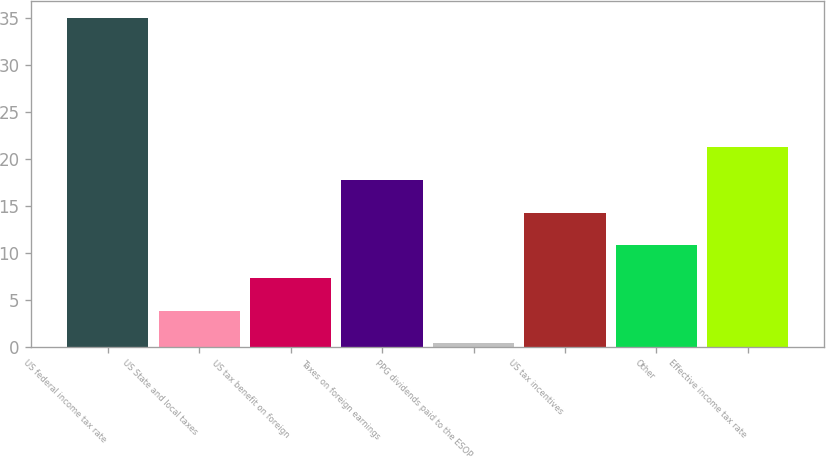<chart> <loc_0><loc_0><loc_500><loc_500><bar_chart><fcel>US federal income tax rate<fcel>US State and local taxes<fcel>US tax benefit on foreign<fcel>Taxes on foreign earnings<fcel>PPG dividends paid to the ESOP<fcel>US tax incentives<fcel>Other<fcel>Effective income tax rate<nl><fcel>35<fcel>3.86<fcel>7.32<fcel>17.7<fcel>0.4<fcel>14.24<fcel>10.78<fcel>21.3<nl></chart> 